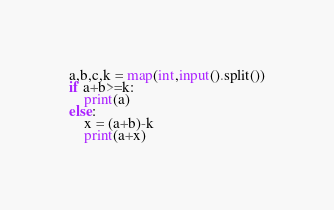Convert code to text. <code><loc_0><loc_0><loc_500><loc_500><_Python_>a,b,c,k = map(int,input().split())
if a+b>=k:
    print(a)
else:
    x = (a+b)-k
    print(a+x)</code> 